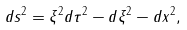<formula> <loc_0><loc_0><loc_500><loc_500>d s ^ { 2 } = \xi ^ { 2 } d \tau ^ { 2 } - d \xi ^ { 2 } - d x ^ { 2 } ,</formula> 